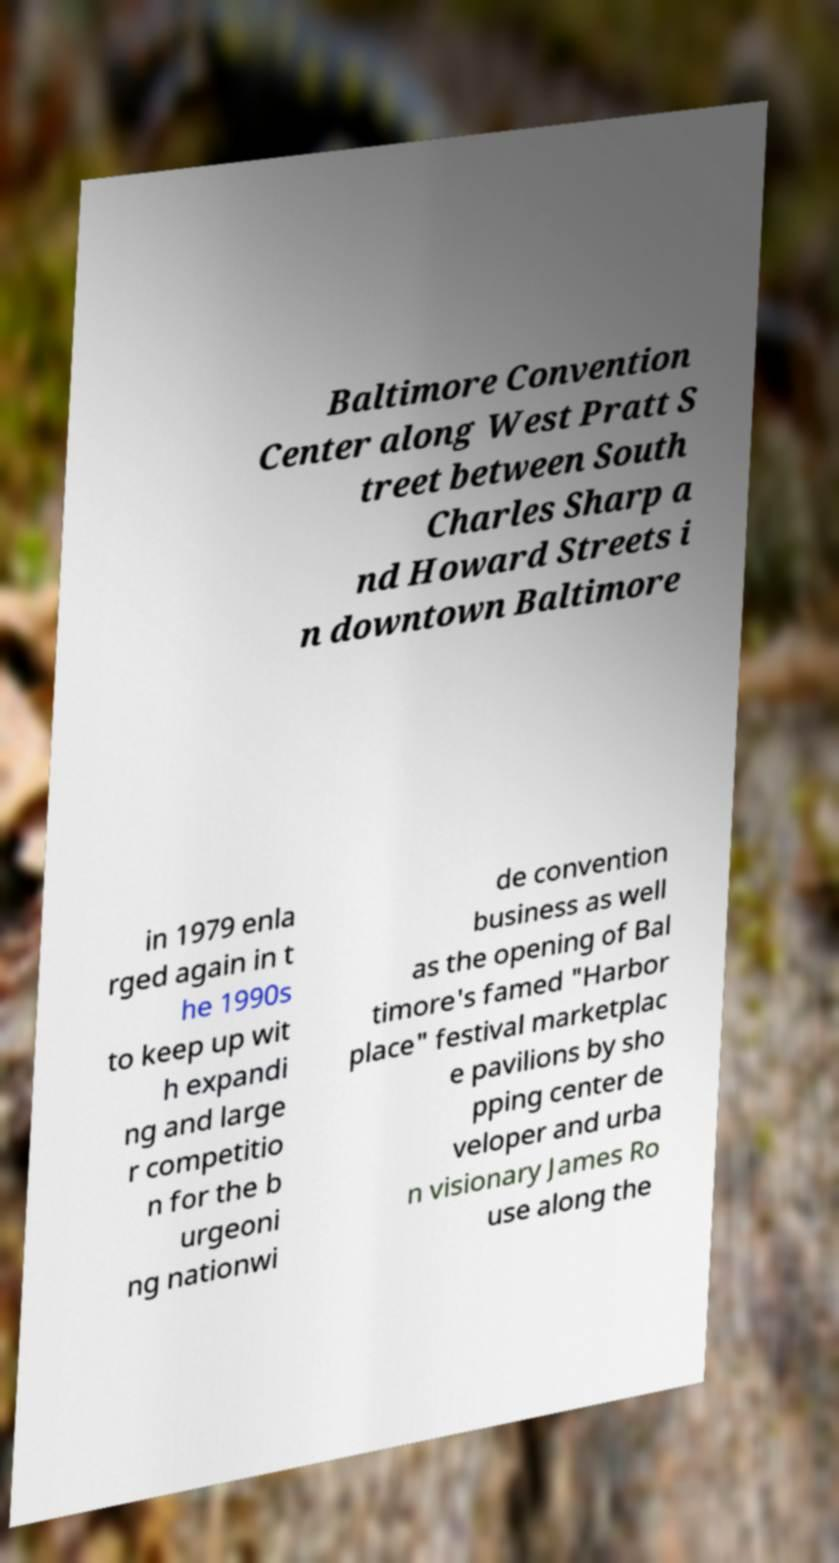I need the written content from this picture converted into text. Can you do that? Baltimore Convention Center along West Pratt S treet between South Charles Sharp a nd Howard Streets i n downtown Baltimore in 1979 enla rged again in t he 1990s to keep up wit h expandi ng and large r competitio n for the b urgeoni ng nationwi de convention business as well as the opening of Bal timore's famed "Harbor place" festival marketplac e pavilions by sho pping center de veloper and urba n visionary James Ro use along the 